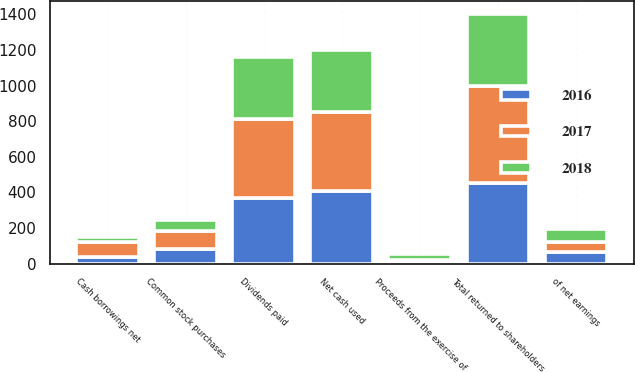Convert chart to OTSL. <chart><loc_0><loc_0><loc_500><loc_500><stacked_bar_chart><ecel><fcel>Dividends paid<fcel>of net earnings<fcel>Common stock purchases<fcel>Total returned to shareholders<fcel>Proceeds from the exercise of<fcel>Cash borrowings net<fcel>Net cash used<nl><fcel>2017<fcel>441.9<fcel>58.8<fcel>103<fcel>544.9<fcel>13.4<fcel>85<fcel>446.5<nl><fcel>2016<fcel>369.1<fcel>63.8<fcel>82.6<fcel>451.7<fcel>9.5<fcel>35<fcel>407.2<nl><fcel>2018<fcel>346.6<fcel>69.4<fcel>59.5<fcel>406.1<fcel>29.3<fcel>30<fcel>346.8<nl></chart> 